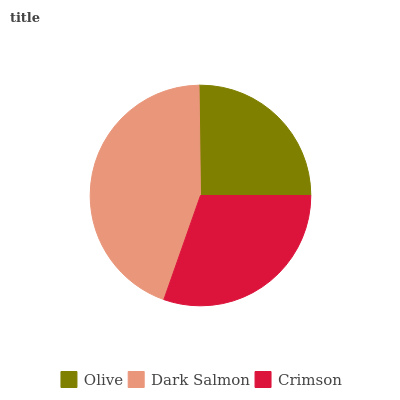Is Olive the minimum?
Answer yes or no. Yes. Is Dark Salmon the maximum?
Answer yes or no. Yes. Is Crimson the minimum?
Answer yes or no. No. Is Crimson the maximum?
Answer yes or no. No. Is Dark Salmon greater than Crimson?
Answer yes or no. Yes. Is Crimson less than Dark Salmon?
Answer yes or no. Yes. Is Crimson greater than Dark Salmon?
Answer yes or no. No. Is Dark Salmon less than Crimson?
Answer yes or no. No. Is Crimson the high median?
Answer yes or no. Yes. Is Crimson the low median?
Answer yes or no. Yes. Is Olive the high median?
Answer yes or no. No. Is Dark Salmon the low median?
Answer yes or no. No. 